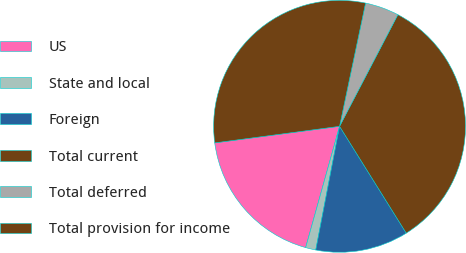Convert chart to OTSL. <chart><loc_0><loc_0><loc_500><loc_500><pie_chart><fcel>US<fcel>State and local<fcel>Foreign<fcel>Total current<fcel>Total deferred<fcel>Total provision for income<nl><fcel>18.56%<fcel>1.31%<fcel>11.91%<fcel>33.46%<fcel>4.35%<fcel>30.41%<nl></chart> 